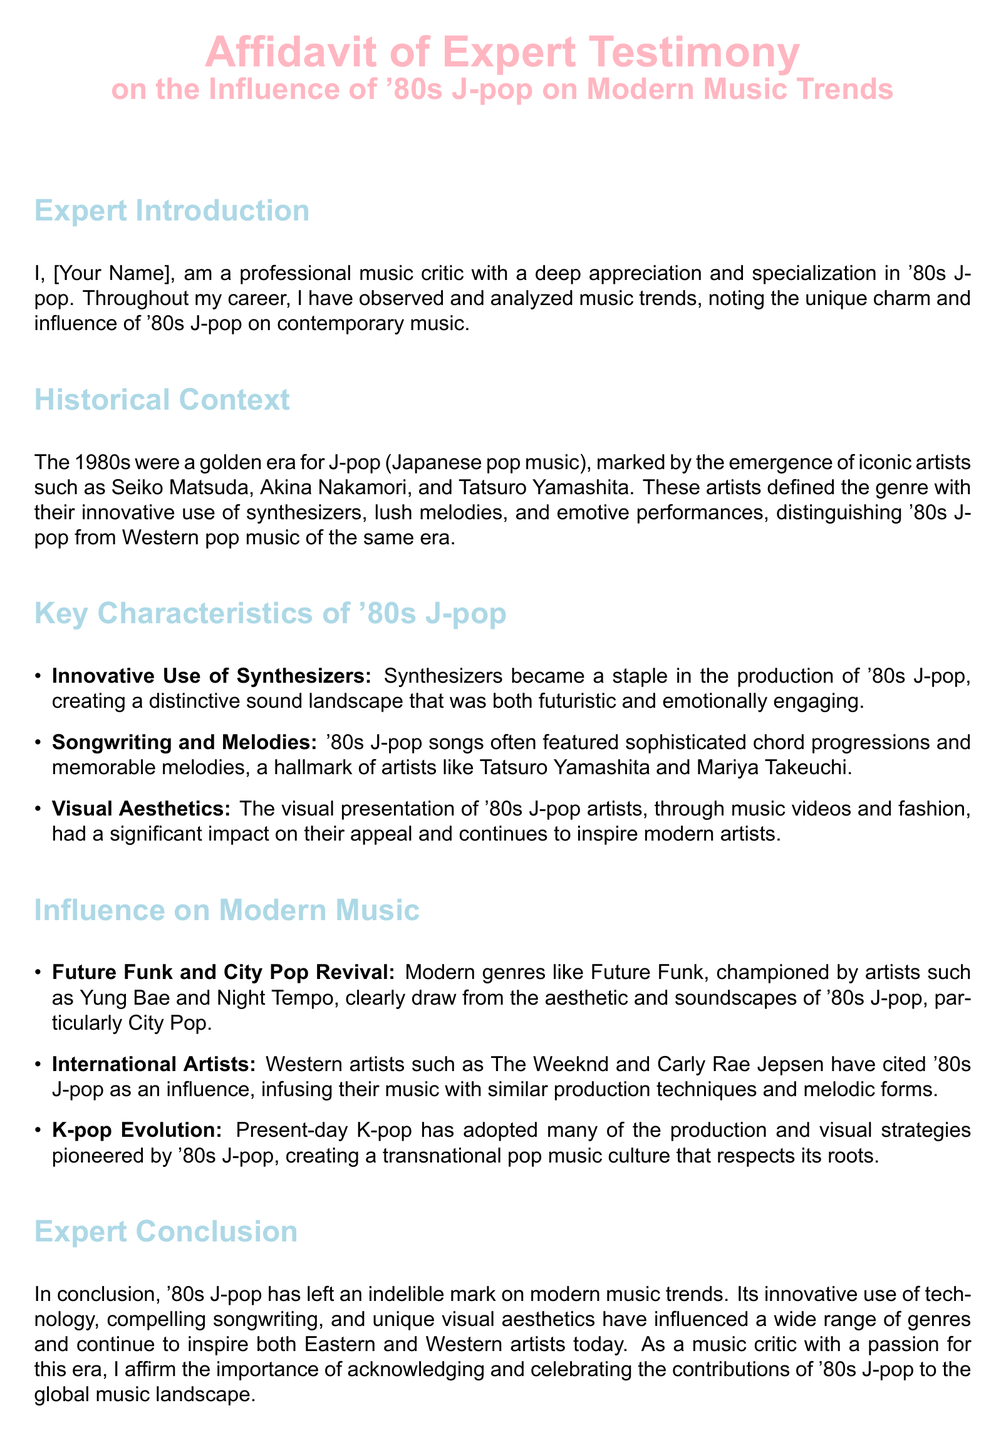What is the title of the affidavit? The title of the affidavit is prominently displayed at the top and is "Affidavit of Expert Testimony on the Influence of '80s J-pop on Modern Music Trends."
Answer: Affidavit of Expert Testimony on the Influence of '80s J-pop on Modern Music Trends Who is the expert? The expert's name is mentioned in the introduction section, indicating that they are a professional music critic with a specialization in '80s J-pop.
Answer: [Your Name] What era is referred to as a golden era for J-pop? The document discusses the 1980s as the golden era for J-pop, highlighting the emergence of key artists during this time.
Answer: 1980s Which artist is associated with innovative synthesizer use in '80s J-pop? The document mentions that the innovative use of synthesizers is a characteristic of '80s J-pop, particularly attributed to artists like Tatsuro Yamashita.
Answer: Tatsuro Yamashita What modern genre is influenced by '80s J-pop? The section on modern music influences states that Future Funk is a modern genre that clearly draws from '80s J-pop.
Answer: Future Funk Which international artist is mentioned as being influenced by '80s J-pop? The document lists The Weeknd as an international artist who has cited '80s J-pop as an influence.
Answer: The Weeknd What production strategy is noted as being adopted by present-day K-pop? The document explains that present-day K-pop has adopted many production strategies pioneered by '80s J-pop.
Answer: Production strategies Who is quoted as affirming the influence of '80s J-pop? The affidavit concludes with the expert affirming the importance of '80s J-pop's contributions to music, which is attributed to the expert themselves, noted as "I."
Answer: I What color is used for the headings in the document? The headings are styled with a specific color, which is identified as jpopblue in the document.
Answer: jpopblue 